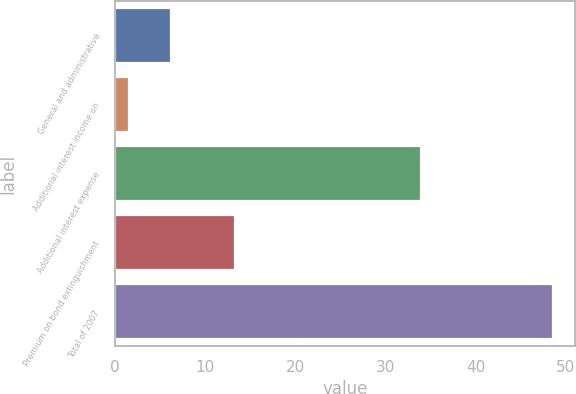<chart> <loc_0><loc_0><loc_500><loc_500><bar_chart><fcel>General and administrative<fcel>Additional interest income on<fcel>Additional interest expense<fcel>Premium on bond extinguishment<fcel>Total of 2007<nl><fcel>6.21<fcel>1.5<fcel>33.9<fcel>13.3<fcel>48.6<nl></chart> 